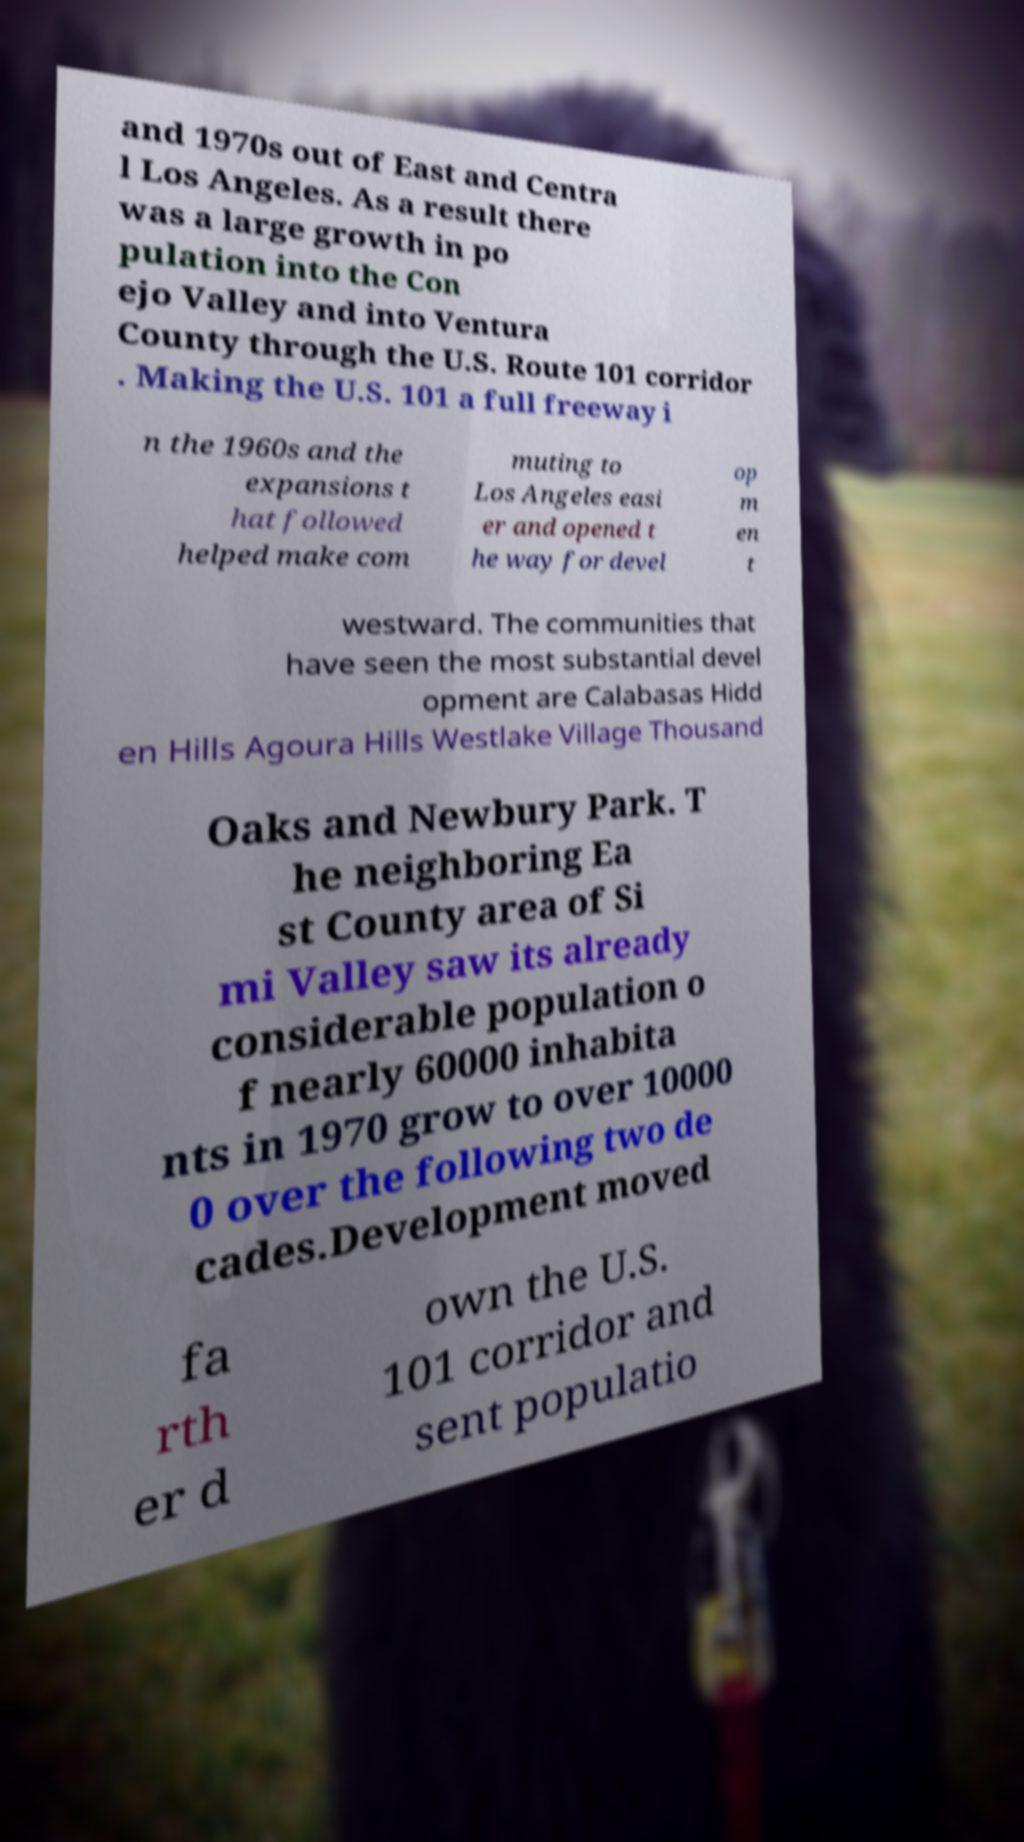Please read and relay the text visible in this image. What does it say? and 1970s out of East and Centra l Los Angeles. As a result there was a large growth in po pulation into the Con ejo Valley and into Ventura County through the U.S. Route 101 corridor . Making the U.S. 101 a full freeway i n the 1960s and the expansions t hat followed helped make com muting to Los Angeles easi er and opened t he way for devel op m en t westward. The communities that have seen the most substantial devel opment are Calabasas Hidd en Hills Agoura Hills Westlake Village Thousand Oaks and Newbury Park. T he neighboring Ea st County area of Si mi Valley saw its already considerable population o f nearly 60000 inhabita nts in 1970 grow to over 10000 0 over the following two de cades.Development moved fa rth er d own the U.S. 101 corridor and sent populatio 